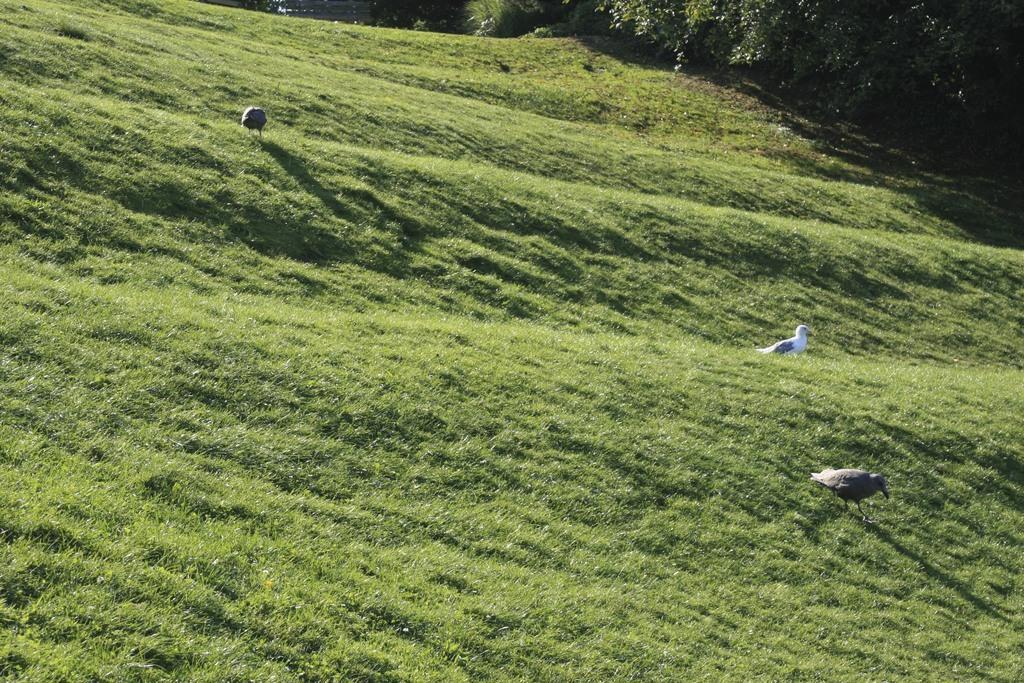Describe this image in one or two sentences. In this image we can see there are birds on the ground. And there are trees and grass. 